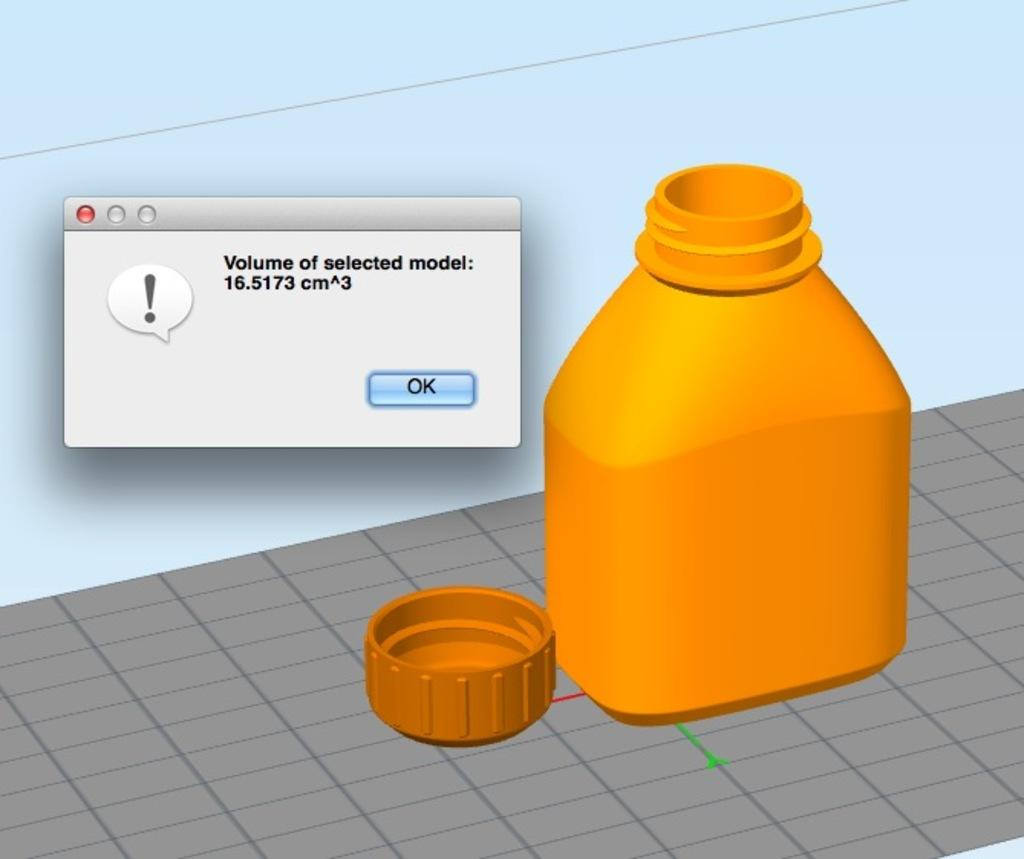What object is present in the image that can hold liquid? There is a bottle in the image that can hold liquid. Where is the cap of the bottle located? The cap of the bottle is on the floor. What additional feature is present in the image? There is a pop-up box with text in the image. What can be found within the pop-up box? There is a button in the pop-up box. How many baskets are visible in the image? There are no baskets visible in the image. What type of sleep can be seen in the image? There is no sleep depicted in the image. 